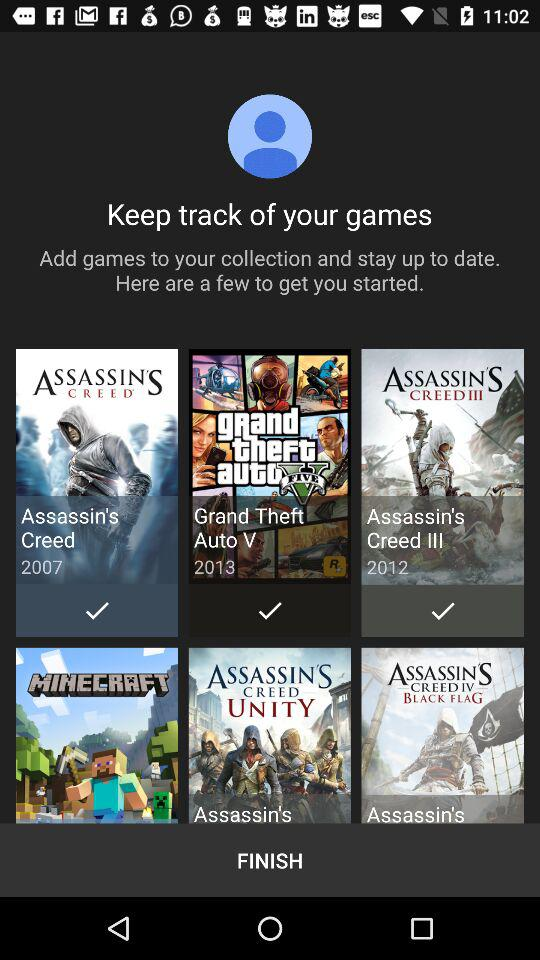What is the release year of "Assassin's Creed III"? The release year is 2012. 